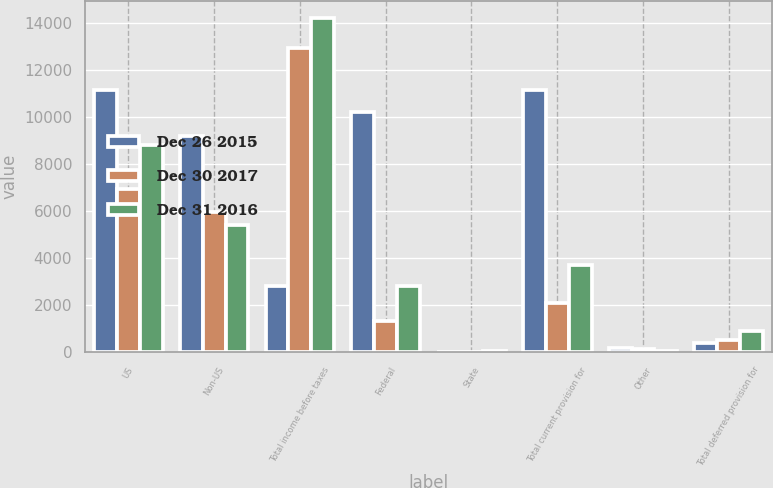Convert chart. <chart><loc_0><loc_0><loc_500><loc_500><stacked_bar_chart><ecel><fcel>US<fcel>Non-US<fcel>Total income before taxes<fcel>Federal<fcel>State<fcel>Total current provision for<fcel>Other<fcel>Total deferred provision for<nl><fcel>Dec 26 2015<fcel>11141<fcel>9211<fcel>2828<fcel>10207<fcel>27<fcel>11133<fcel>162<fcel>382<nl><fcel>Dec 30 2017<fcel>6957<fcel>5979<fcel>12936<fcel>1319<fcel>13<fcel>2088<fcel>126<fcel>532<nl><fcel>Dec 31 2016<fcel>8800<fcel>5412<fcel>14212<fcel>2828<fcel>40<fcel>3710<fcel>56<fcel>918<nl></chart> 